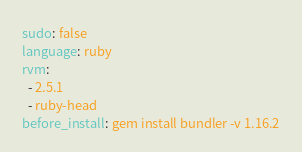Convert code to text. <code><loc_0><loc_0><loc_500><loc_500><_YAML_>sudo: false
language: ruby
rvm:
  - 2.5.1
  - ruby-head  
before_install: gem install bundler -v 1.16.2
</code> 